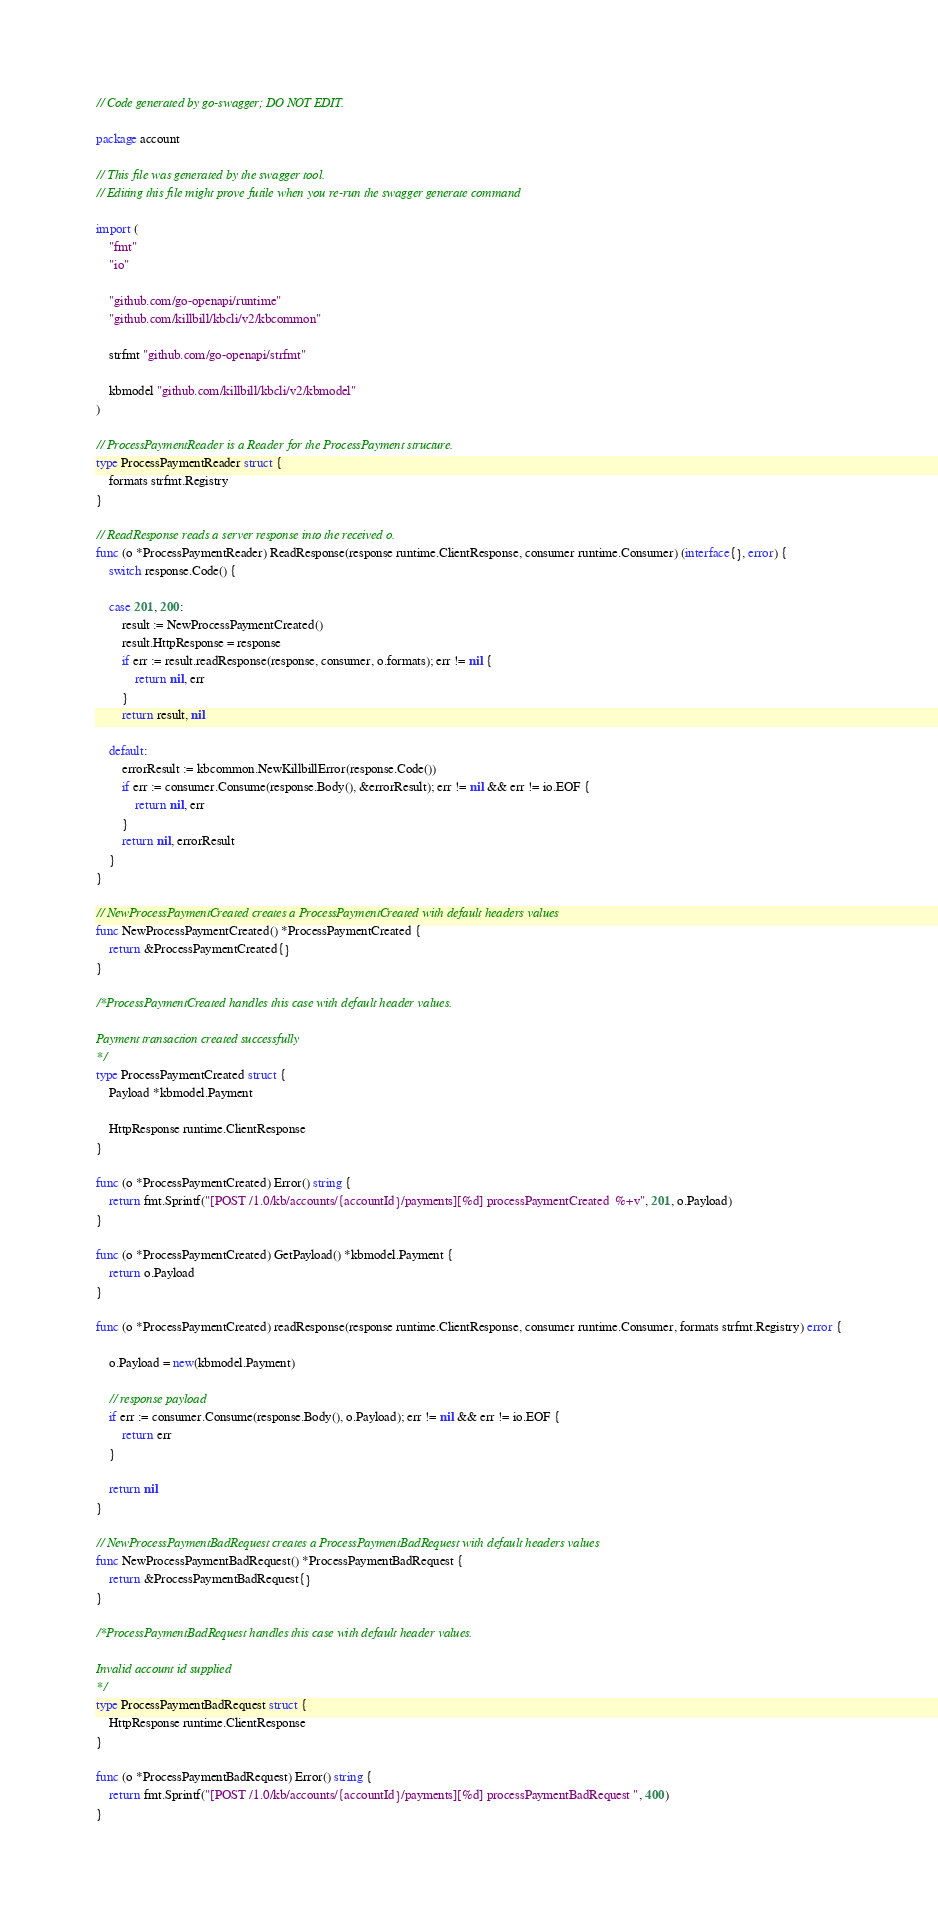Convert code to text. <code><loc_0><loc_0><loc_500><loc_500><_Go_>// Code generated by go-swagger; DO NOT EDIT.

package account

// This file was generated by the swagger tool.
// Editing this file might prove futile when you re-run the swagger generate command

import (
	"fmt"
	"io"

	"github.com/go-openapi/runtime"
	"github.com/killbill/kbcli/v2/kbcommon"

	strfmt "github.com/go-openapi/strfmt"

	kbmodel "github.com/killbill/kbcli/v2/kbmodel"
)

// ProcessPaymentReader is a Reader for the ProcessPayment structure.
type ProcessPaymentReader struct {
	formats strfmt.Registry
}

// ReadResponse reads a server response into the received o.
func (o *ProcessPaymentReader) ReadResponse(response runtime.ClientResponse, consumer runtime.Consumer) (interface{}, error) {
	switch response.Code() {

	case 201, 200:
		result := NewProcessPaymentCreated()
		result.HttpResponse = response
		if err := result.readResponse(response, consumer, o.formats); err != nil {
			return nil, err
		}
		return result, nil

	default:
		errorResult := kbcommon.NewKillbillError(response.Code())
		if err := consumer.Consume(response.Body(), &errorResult); err != nil && err != io.EOF {
			return nil, err
		}
		return nil, errorResult
	}
}

// NewProcessPaymentCreated creates a ProcessPaymentCreated with default headers values
func NewProcessPaymentCreated() *ProcessPaymentCreated {
	return &ProcessPaymentCreated{}
}

/*ProcessPaymentCreated handles this case with default header values.

Payment transaction created successfully
*/
type ProcessPaymentCreated struct {
	Payload *kbmodel.Payment

	HttpResponse runtime.ClientResponse
}

func (o *ProcessPaymentCreated) Error() string {
	return fmt.Sprintf("[POST /1.0/kb/accounts/{accountId}/payments][%d] processPaymentCreated  %+v", 201, o.Payload)
}

func (o *ProcessPaymentCreated) GetPayload() *kbmodel.Payment {
	return o.Payload
}

func (o *ProcessPaymentCreated) readResponse(response runtime.ClientResponse, consumer runtime.Consumer, formats strfmt.Registry) error {

	o.Payload = new(kbmodel.Payment)

	// response payload
	if err := consumer.Consume(response.Body(), o.Payload); err != nil && err != io.EOF {
		return err
	}

	return nil
}

// NewProcessPaymentBadRequest creates a ProcessPaymentBadRequest with default headers values
func NewProcessPaymentBadRequest() *ProcessPaymentBadRequest {
	return &ProcessPaymentBadRequest{}
}

/*ProcessPaymentBadRequest handles this case with default header values.

Invalid account id supplied
*/
type ProcessPaymentBadRequest struct {
	HttpResponse runtime.ClientResponse
}

func (o *ProcessPaymentBadRequest) Error() string {
	return fmt.Sprintf("[POST /1.0/kb/accounts/{accountId}/payments][%d] processPaymentBadRequest ", 400)
}
</code> 